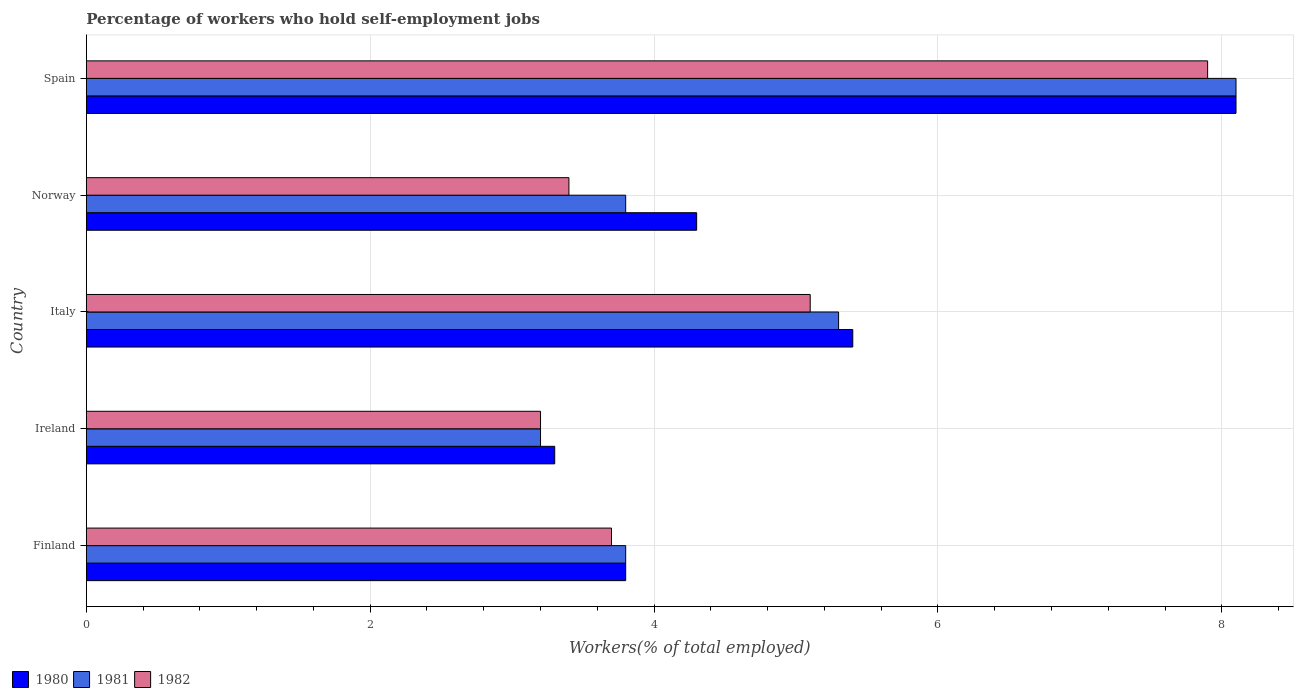How many different coloured bars are there?
Give a very brief answer. 3. How many groups of bars are there?
Make the answer very short. 5. Are the number of bars per tick equal to the number of legend labels?
Give a very brief answer. Yes. What is the label of the 1st group of bars from the top?
Your answer should be very brief. Spain. In how many cases, is the number of bars for a given country not equal to the number of legend labels?
Give a very brief answer. 0. What is the percentage of self-employed workers in 1981 in Finland?
Make the answer very short. 3.8. Across all countries, what is the maximum percentage of self-employed workers in 1980?
Your answer should be compact. 8.1. Across all countries, what is the minimum percentage of self-employed workers in 1980?
Your answer should be very brief. 3.3. In which country was the percentage of self-employed workers in 1981 maximum?
Ensure brevity in your answer.  Spain. In which country was the percentage of self-employed workers in 1980 minimum?
Provide a succinct answer. Ireland. What is the total percentage of self-employed workers in 1981 in the graph?
Your answer should be compact. 24.2. What is the difference between the percentage of self-employed workers in 1981 in Finland and that in Spain?
Make the answer very short. -4.3. What is the difference between the percentage of self-employed workers in 1980 in Spain and the percentage of self-employed workers in 1982 in Ireland?
Your answer should be very brief. 4.9. What is the average percentage of self-employed workers in 1980 per country?
Offer a terse response. 4.98. What is the difference between the percentage of self-employed workers in 1982 and percentage of self-employed workers in 1980 in Norway?
Offer a very short reply. -0.9. In how many countries, is the percentage of self-employed workers in 1982 greater than 6.8 %?
Your response must be concise. 1. What is the ratio of the percentage of self-employed workers in 1981 in Finland to that in Spain?
Your answer should be very brief. 0.47. Is the difference between the percentage of self-employed workers in 1982 in Finland and Norway greater than the difference between the percentage of self-employed workers in 1980 in Finland and Norway?
Provide a short and direct response. Yes. What is the difference between the highest and the second highest percentage of self-employed workers in 1981?
Your answer should be compact. 2.8. What is the difference between the highest and the lowest percentage of self-employed workers in 1980?
Your response must be concise. 4.8. What does the 3rd bar from the top in Finland represents?
Offer a very short reply. 1980. Is it the case that in every country, the sum of the percentage of self-employed workers in 1982 and percentage of self-employed workers in 1980 is greater than the percentage of self-employed workers in 1981?
Offer a very short reply. Yes. Does the graph contain grids?
Provide a short and direct response. Yes. How are the legend labels stacked?
Give a very brief answer. Horizontal. What is the title of the graph?
Provide a short and direct response. Percentage of workers who hold self-employment jobs. What is the label or title of the X-axis?
Make the answer very short. Workers(% of total employed). What is the Workers(% of total employed) in 1980 in Finland?
Ensure brevity in your answer.  3.8. What is the Workers(% of total employed) in 1981 in Finland?
Give a very brief answer. 3.8. What is the Workers(% of total employed) of 1982 in Finland?
Offer a terse response. 3.7. What is the Workers(% of total employed) of 1980 in Ireland?
Keep it short and to the point. 3.3. What is the Workers(% of total employed) of 1981 in Ireland?
Keep it short and to the point. 3.2. What is the Workers(% of total employed) in 1982 in Ireland?
Ensure brevity in your answer.  3.2. What is the Workers(% of total employed) in 1980 in Italy?
Your response must be concise. 5.4. What is the Workers(% of total employed) of 1981 in Italy?
Ensure brevity in your answer.  5.3. What is the Workers(% of total employed) of 1982 in Italy?
Your response must be concise. 5.1. What is the Workers(% of total employed) in 1980 in Norway?
Provide a succinct answer. 4.3. What is the Workers(% of total employed) in 1981 in Norway?
Provide a short and direct response. 3.8. What is the Workers(% of total employed) of 1982 in Norway?
Your answer should be compact. 3.4. What is the Workers(% of total employed) in 1980 in Spain?
Offer a very short reply. 8.1. What is the Workers(% of total employed) of 1981 in Spain?
Ensure brevity in your answer.  8.1. What is the Workers(% of total employed) of 1982 in Spain?
Provide a short and direct response. 7.9. Across all countries, what is the maximum Workers(% of total employed) in 1980?
Provide a short and direct response. 8.1. Across all countries, what is the maximum Workers(% of total employed) of 1981?
Offer a terse response. 8.1. Across all countries, what is the maximum Workers(% of total employed) of 1982?
Offer a terse response. 7.9. Across all countries, what is the minimum Workers(% of total employed) of 1980?
Make the answer very short. 3.3. Across all countries, what is the minimum Workers(% of total employed) of 1981?
Offer a terse response. 3.2. Across all countries, what is the minimum Workers(% of total employed) of 1982?
Your response must be concise. 3.2. What is the total Workers(% of total employed) in 1980 in the graph?
Offer a very short reply. 24.9. What is the total Workers(% of total employed) of 1981 in the graph?
Your answer should be very brief. 24.2. What is the total Workers(% of total employed) of 1982 in the graph?
Provide a short and direct response. 23.3. What is the difference between the Workers(% of total employed) of 1981 in Finland and that in Ireland?
Provide a short and direct response. 0.6. What is the difference between the Workers(% of total employed) in 1982 in Finland and that in Ireland?
Your answer should be compact. 0.5. What is the difference between the Workers(% of total employed) in 1980 in Finland and that in Italy?
Your answer should be very brief. -1.6. What is the difference between the Workers(% of total employed) in 1982 in Finland and that in Norway?
Give a very brief answer. 0.3. What is the difference between the Workers(% of total employed) of 1981 in Ireland and that in Italy?
Keep it short and to the point. -2.1. What is the difference between the Workers(% of total employed) in 1982 in Ireland and that in Italy?
Provide a succinct answer. -1.9. What is the difference between the Workers(% of total employed) of 1981 in Ireland and that in Norway?
Provide a short and direct response. -0.6. What is the difference between the Workers(% of total employed) in 1982 in Ireland and that in Norway?
Provide a short and direct response. -0.2. What is the difference between the Workers(% of total employed) of 1980 in Italy and that in Norway?
Provide a short and direct response. 1.1. What is the difference between the Workers(% of total employed) of 1981 in Italy and that in Spain?
Offer a very short reply. -2.8. What is the difference between the Workers(% of total employed) in 1982 in Italy and that in Spain?
Provide a short and direct response. -2.8. What is the difference between the Workers(% of total employed) of 1980 in Norway and that in Spain?
Provide a succinct answer. -3.8. What is the difference between the Workers(% of total employed) in 1981 in Norway and that in Spain?
Your answer should be compact. -4.3. What is the difference between the Workers(% of total employed) in 1980 in Finland and the Workers(% of total employed) in 1982 in Ireland?
Offer a terse response. 0.6. What is the difference between the Workers(% of total employed) of 1981 in Finland and the Workers(% of total employed) of 1982 in Ireland?
Keep it short and to the point. 0.6. What is the difference between the Workers(% of total employed) of 1980 in Finland and the Workers(% of total employed) of 1981 in Italy?
Your response must be concise. -1.5. What is the difference between the Workers(% of total employed) in 1980 in Finland and the Workers(% of total employed) in 1982 in Italy?
Make the answer very short. -1.3. What is the difference between the Workers(% of total employed) in 1980 in Finland and the Workers(% of total employed) in 1981 in Norway?
Offer a very short reply. 0. What is the difference between the Workers(% of total employed) of 1980 in Finland and the Workers(% of total employed) of 1982 in Norway?
Ensure brevity in your answer.  0.4. What is the difference between the Workers(% of total employed) of 1980 in Finland and the Workers(% of total employed) of 1982 in Spain?
Provide a succinct answer. -4.1. What is the difference between the Workers(% of total employed) of 1981 in Finland and the Workers(% of total employed) of 1982 in Spain?
Your answer should be very brief. -4.1. What is the difference between the Workers(% of total employed) in 1980 in Ireland and the Workers(% of total employed) in 1981 in Italy?
Provide a succinct answer. -2. What is the difference between the Workers(% of total employed) of 1980 in Ireland and the Workers(% of total employed) of 1982 in Italy?
Provide a succinct answer. -1.8. What is the difference between the Workers(% of total employed) of 1980 in Ireland and the Workers(% of total employed) of 1982 in Spain?
Your response must be concise. -4.6. What is the difference between the Workers(% of total employed) of 1981 in Ireland and the Workers(% of total employed) of 1982 in Spain?
Provide a short and direct response. -4.7. What is the difference between the Workers(% of total employed) in 1980 in Italy and the Workers(% of total employed) in 1981 in Norway?
Your answer should be compact. 1.6. What is the difference between the Workers(% of total employed) in 1980 in Italy and the Workers(% of total employed) in 1982 in Norway?
Provide a succinct answer. 2. What is the difference between the Workers(% of total employed) of 1981 in Italy and the Workers(% of total employed) of 1982 in Norway?
Offer a terse response. 1.9. What is the difference between the Workers(% of total employed) of 1980 in Italy and the Workers(% of total employed) of 1981 in Spain?
Keep it short and to the point. -2.7. What is the difference between the Workers(% of total employed) of 1980 in Norway and the Workers(% of total employed) of 1981 in Spain?
Your answer should be very brief. -3.8. What is the difference between the Workers(% of total employed) of 1980 in Norway and the Workers(% of total employed) of 1982 in Spain?
Your response must be concise. -3.6. What is the average Workers(% of total employed) in 1980 per country?
Your answer should be compact. 4.98. What is the average Workers(% of total employed) of 1981 per country?
Your answer should be compact. 4.84. What is the average Workers(% of total employed) of 1982 per country?
Offer a very short reply. 4.66. What is the difference between the Workers(% of total employed) in 1980 and Workers(% of total employed) in 1981 in Finland?
Offer a very short reply. 0. What is the difference between the Workers(% of total employed) in 1980 and Workers(% of total employed) in 1982 in Finland?
Keep it short and to the point. 0.1. What is the difference between the Workers(% of total employed) of 1981 and Workers(% of total employed) of 1982 in Finland?
Offer a terse response. 0.1. What is the difference between the Workers(% of total employed) of 1980 and Workers(% of total employed) of 1981 in Ireland?
Ensure brevity in your answer.  0.1. What is the difference between the Workers(% of total employed) of 1980 and Workers(% of total employed) of 1982 in Ireland?
Make the answer very short. 0.1. What is the difference between the Workers(% of total employed) in 1981 and Workers(% of total employed) in 1982 in Ireland?
Provide a short and direct response. 0. What is the difference between the Workers(% of total employed) of 1980 and Workers(% of total employed) of 1981 in Italy?
Keep it short and to the point. 0.1. What is the difference between the Workers(% of total employed) of 1980 and Workers(% of total employed) of 1982 in Italy?
Offer a very short reply. 0.3. What is the difference between the Workers(% of total employed) in 1981 and Workers(% of total employed) in 1982 in Italy?
Provide a succinct answer. 0.2. What is the difference between the Workers(% of total employed) of 1980 and Workers(% of total employed) of 1981 in Norway?
Make the answer very short. 0.5. What is the difference between the Workers(% of total employed) in 1980 and Workers(% of total employed) in 1982 in Norway?
Offer a very short reply. 0.9. What is the difference between the Workers(% of total employed) in 1980 and Workers(% of total employed) in 1982 in Spain?
Your response must be concise. 0.2. What is the difference between the Workers(% of total employed) in 1981 and Workers(% of total employed) in 1982 in Spain?
Your response must be concise. 0.2. What is the ratio of the Workers(% of total employed) of 1980 in Finland to that in Ireland?
Your answer should be very brief. 1.15. What is the ratio of the Workers(% of total employed) of 1981 in Finland to that in Ireland?
Your answer should be compact. 1.19. What is the ratio of the Workers(% of total employed) of 1982 in Finland to that in Ireland?
Offer a very short reply. 1.16. What is the ratio of the Workers(% of total employed) of 1980 in Finland to that in Italy?
Offer a very short reply. 0.7. What is the ratio of the Workers(% of total employed) of 1981 in Finland to that in Italy?
Provide a short and direct response. 0.72. What is the ratio of the Workers(% of total employed) of 1982 in Finland to that in Italy?
Make the answer very short. 0.73. What is the ratio of the Workers(% of total employed) of 1980 in Finland to that in Norway?
Ensure brevity in your answer.  0.88. What is the ratio of the Workers(% of total employed) in 1982 in Finland to that in Norway?
Give a very brief answer. 1.09. What is the ratio of the Workers(% of total employed) in 1980 in Finland to that in Spain?
Your response must be concise. 0.47. What is the ratio of the Workers(% of total employed) in 1981 in Finland to that in Spain?
Give a very brief answer. 0.47. What is the ratio of the Workers(% of total employed) in 1982 in Finland to that in Spain?
Provide a short and direct response. 0.47. What is the ratio of the Workers(% of total employed) in 1980 in Ireland to that in Italy?
Keep it short and to the point. 0.61. What is the ratio of the Workers(% of total employed) of 1981 in Ireland to that in Italy?
Give a very brief answer. 0.6. What is the ratio of the Workers(% of total employed) in 1982 in Ireland to that in Italy?
Provide a succinct answer. 0.63. What is the ratio of the Workers(% of total employed) of 1980 in Ireland to that in Norway?
Ensure brevity in your answer.  0.77. What is the ratio of the Workers(% of total employed) in 1981 in Ireland to that in Norway?
Give a very brief answer. 0.84. What is the ratio of the Workers(% of total employed) of 1980 in Ireland to that in Spain?
Provide a short and direct response. 0.41. What is the ratio of the Workers(% of total employed) of 1981 in Ireland to that in Spain?
Keep it short and to the point. 0.4. What is the ratio of the Workers(% of total employed) of 1982 in Ireland to that in Spain?
Ensure brevity in your answer.  0.41. What is the ratio of the Workers(% of total employed) of 1980 in Italy to that in Norway?
Your answer should be compact. 1.26. What is the ratio of the Workers(% of total employed) of 1981 in Italy to that in Norway?
Give a very brief answer. 1.39. What is the ratio of the Workers(% of total employed) in 1981 in Italy to that in Spain?
Make the answer very short. 0.65. What is the ratio of the Workers(% of total employed) in 1982 in Italy to that in Spain?
Offer a very short reply. 0.65. What is the ratio of the Workers(% of total employed) of 1980 in Norway to that in Spain?
Provide a short and direct response. 0.53. What is the ratio of the Workers(% of total employed) of 1981 in Norway to that in Spain?
Offer a terse response. 0.47. What is the ratio of the Workers(% of total employed) of 1982 in Norway to that in Spain?
Give a very brief answer. 0.43. What is the difference between the highest and the lowest Workers(% of total employed) of 1981?
Offer a very short reply. 4.9. 